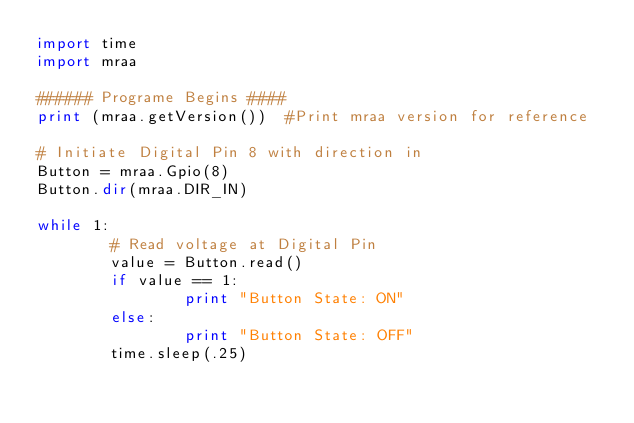Convert code to text. <code><loc_0><loc_0><loc_500><loc_500><_Python_>import time
import mraa

###### Programe Begins ####
print (mraa.getVersion())  #Print mraa version for reference

# Initiate Digital Pin 8 with direction in
Button = mraa.Gpio(8)
Button.dir(mraa.DIR_IN)

while 1:
        # Read voltage at Digital Pin
        value = Button.read()
        if value == 1:
                print "Button State: ON"
        else:
                print "Button State: OFF"
        time.sleep(.25)
</code> 